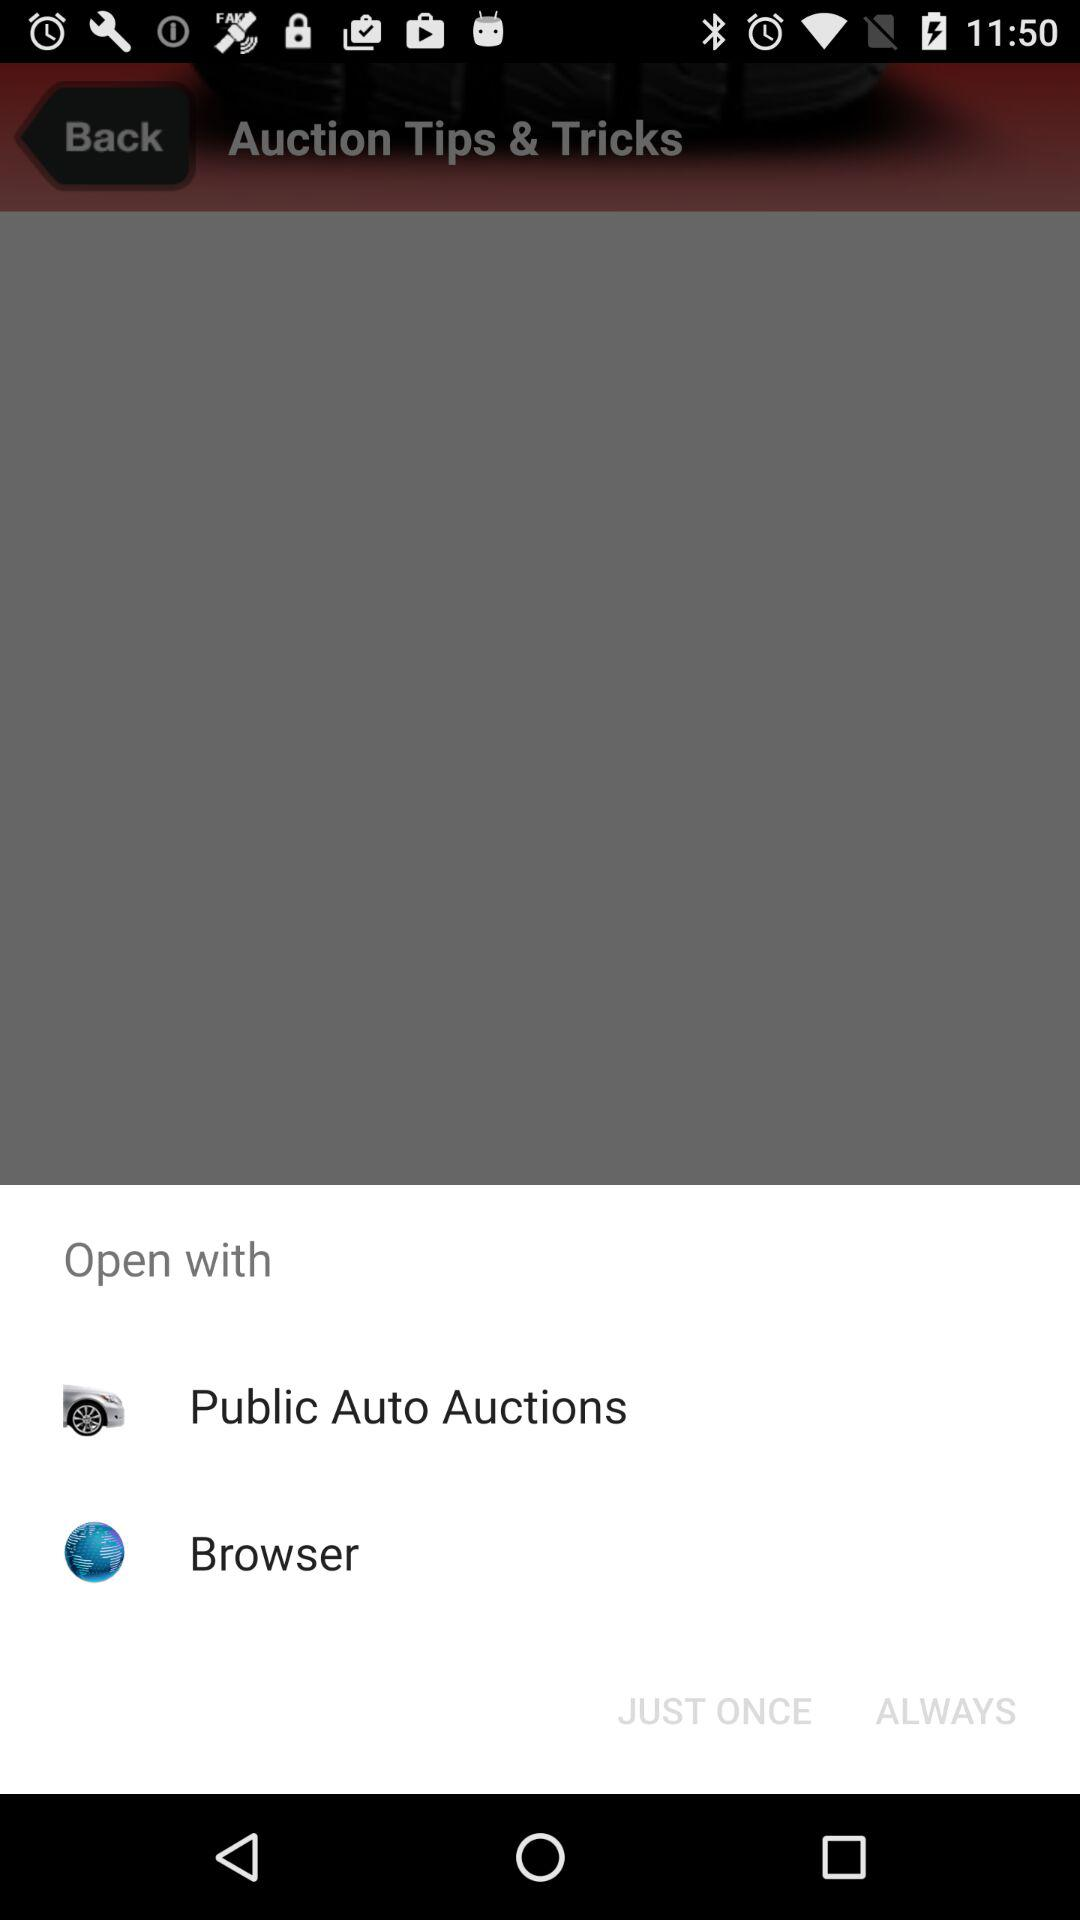Which options are given to open? The given options to open are "Public Auto Auctions" and "Browser". 